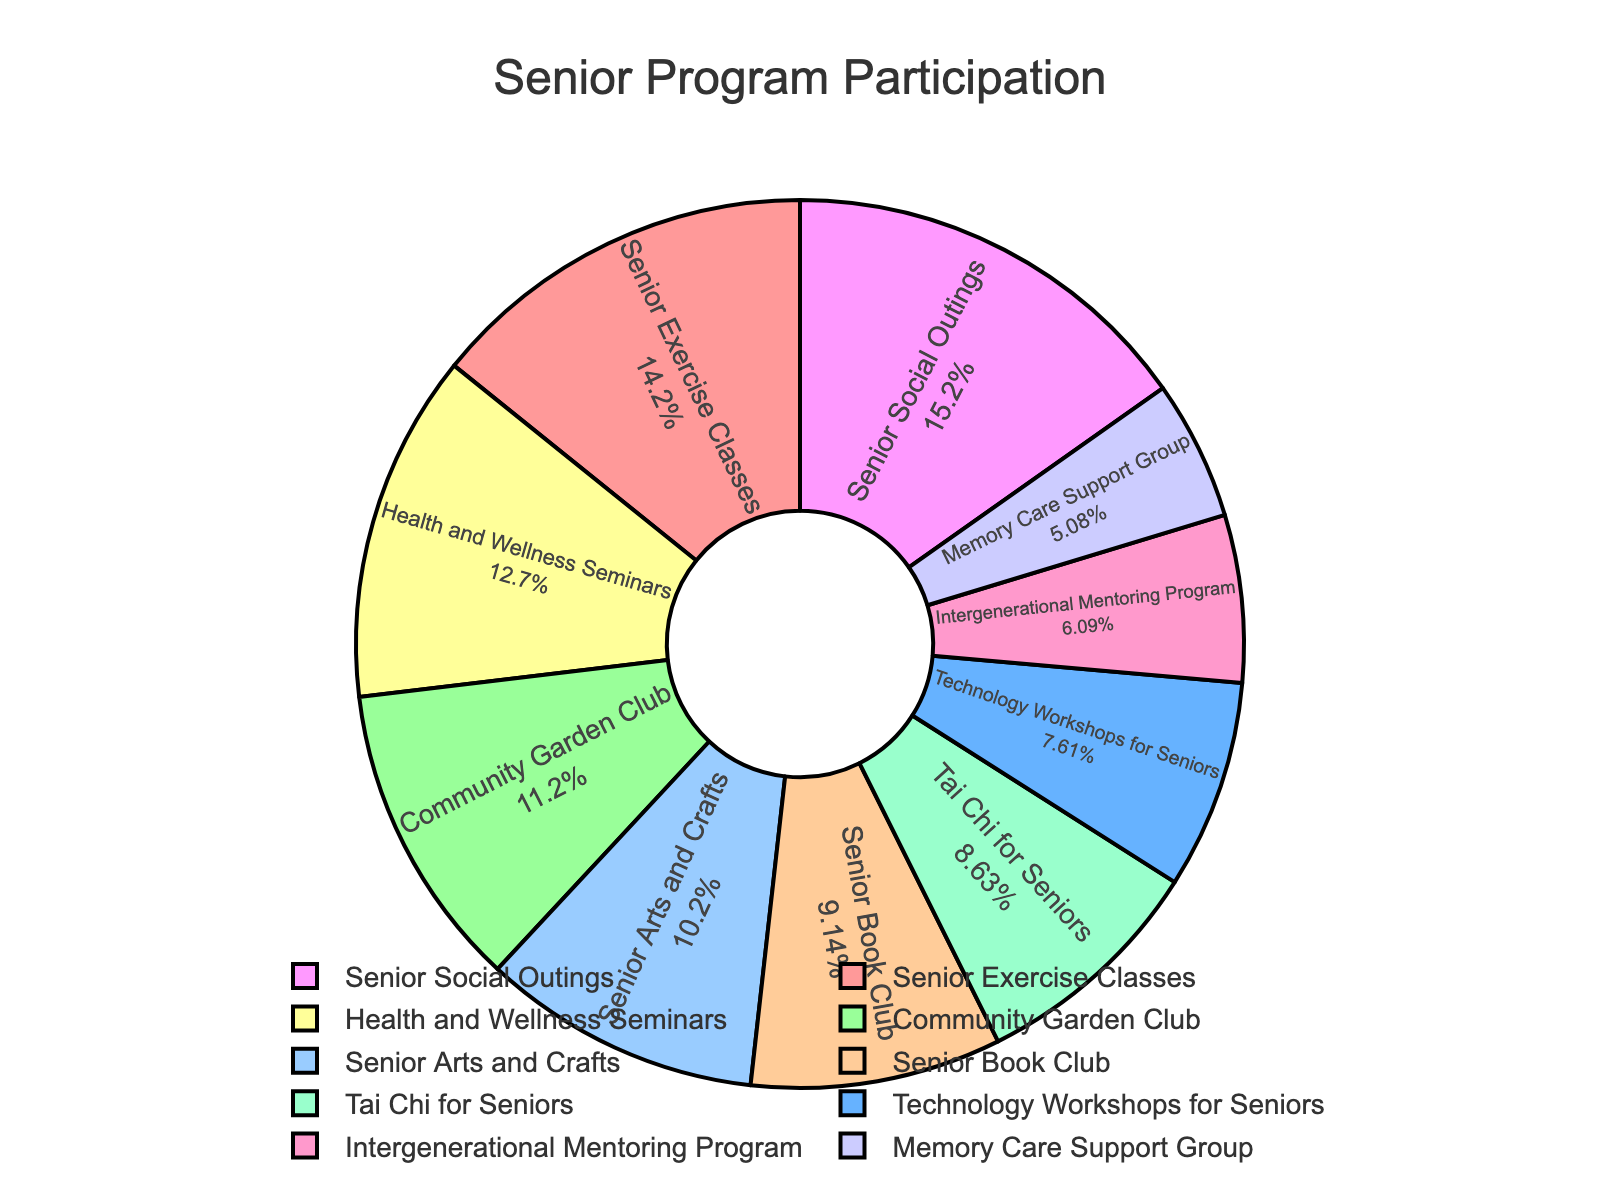Which program has the highest participation? The figure shows a pie chart with segments representing different programs. The largest segment corresponds to the highest participation. The Senior Social Outings program has the largest segment.
Answer: Senior Social Outings Which two programs have the smallest participation? By examining the pie chart, the two smallest segments represent the programs with the smallest number of participants. These are the Memory Care Support Group and the Intergenerational Mentoring Program.
Answer: Memory Care Support Group and Intergenerational Mentoring Program What percentage of participants attended the Health and Wellness Seminars? The pie chart provides percentage labels for each segment. The Health and Wellness Seminars segment has a label indicating the percentage of total participation.
Answer: 17.24% How many participants are there in total? To find the total, sum all the participants for each program: 28+15+22+18+12+20+25+30+17+10 = 197.
Answer: 197 How does the participation in Tai Chi for Seniors compare to that in Senior Exercise Classes? Compare the sizes of the segments in the pie chart representing Tai Chi for Seniors and Senior Exercise Classes. The Senior Exercise Classes segment is larger.
Answer: Senior Exercise Classes is larger What fraction of participants joined the Senior Book Club? Divide the participants in the Senior Book Club (18) by the total number of participants (197), which gives 18/197. Simplifying this fraction results in approximately 0.091.
Answer: 9.1% How many more participants are there in Community Garden Club compared to Memory Care Support Group? Subtract the number of participants in Memory Care Support Group (10) from those in Community Garden Club (22), resulting in 22 - 10 = 12.
Answer: 12 Are there more participants in Technology Workshops for Seniors or Senior Arts and Crafts? Compare the sizes of the segments representing Technology Workshops for Seniors (15) and Senior Arts and Crafts (20). The Senior Arts and Crafts segment is larger.
Answer: Senior Arts and Crafts Which programs have more than 20 participants? From the pie chart, identify the segments with more than 20 participants: Senior Exercise Classes, Health and Wellness Seminars, Senior Social Outings, and Community Garden Club.
Answer: Senior Exercise Classes, Health and Wellness Seminars, Senior Social Outings, and Community Garden Club 